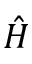<formula> <loc_0><loc_0><loc_500><loc_500>\hat { H }</formula> 